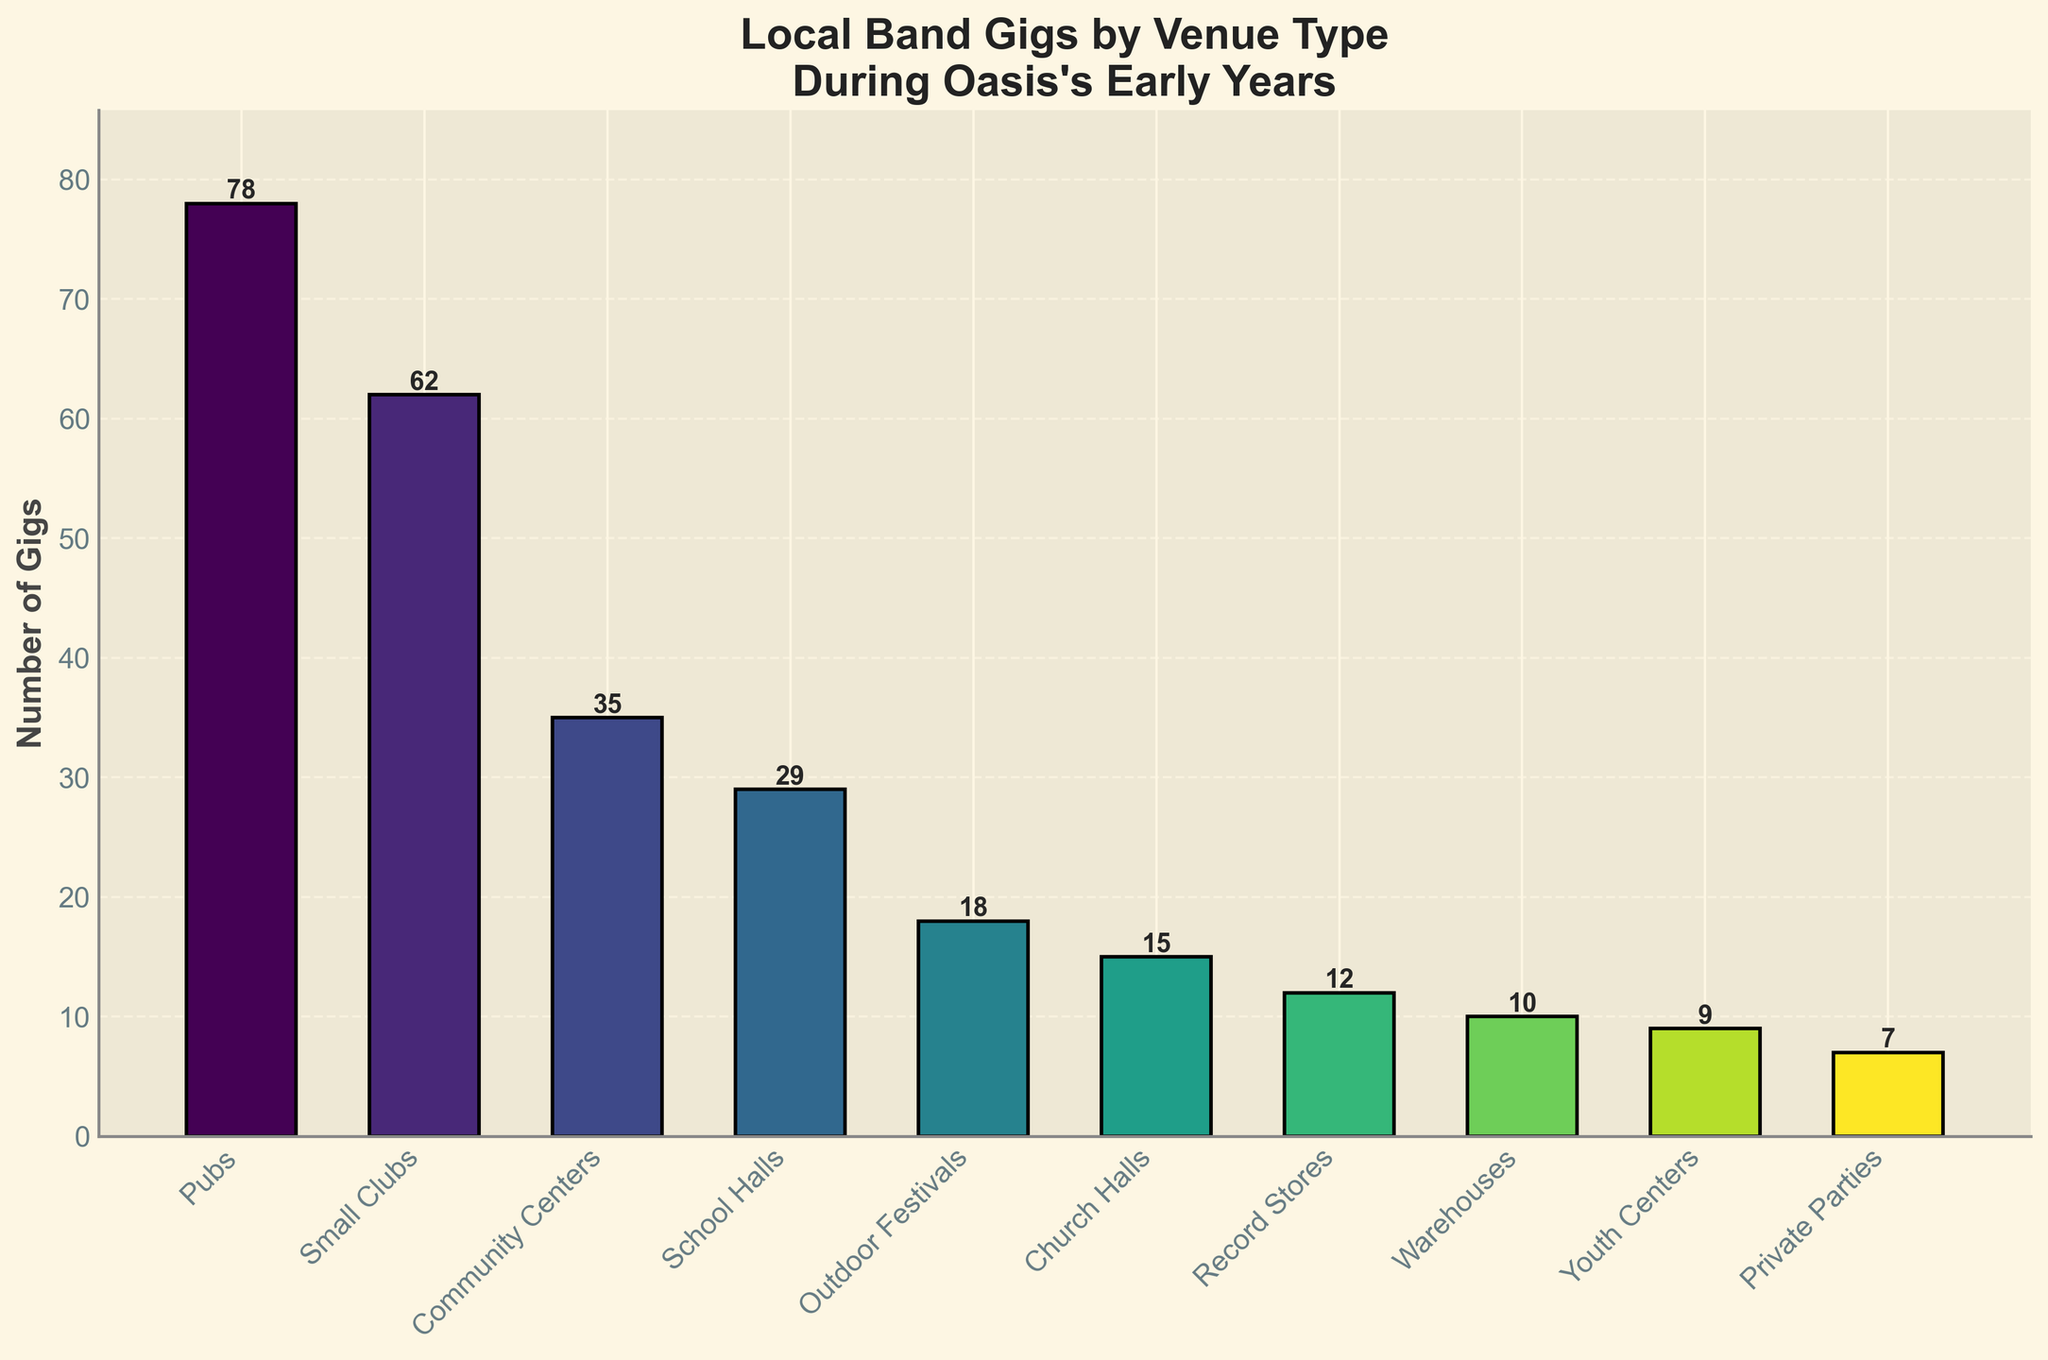Which venue type hosted the most gigs? The highest bar in the chart represents the venue type that hosted the most gigs. The bar for "Pubs" is the tallest.
Answer: Pubs How many gigs were played at Community Centers compared to School Halls? The bar representing Community Centers reaches up to 35, while the bar representing School Halls reaches up to 29.
Answer: Community Centers: 35, School Halls: 29 What is the total number of gigs played at Outdoor Festivals and Church Halls? Summing the heights of the bars for Outdoor Festivals (18) and Church Halls (15) gives the total number. 18 + 15 = 33
Answer: 33 Which venue type hosted the fewest gigs and how many were there? The shortest bar represents the venue type that hosted the fewest gigs. The bar for "Private Parties" is the shortest, reaching up to 7.
Answer: Private Parties, 7 How many more gigs were played at Small Clubs than at Warehouses? The height of the bar for Small Clubs is 62 and for Warehouses, it is 10. The difference is 62 - 10 = 52.
Answer: 52 What is the average number of gigs played across all recorded venue types? Adding up the heights of all bars and dividing by the number of venue types: (78 + 62 + 35 + 29 + 18 + 15 + 12 + 10 + 9 + 7) / 10 = 275 / 10 = 27.5
Answer: 27.5 How does the number of gigs at Record Stores compare to those at Warehouses? The bar for Record Stores reaches up to 12 and the bar for Warehouses reaches up to 10, so Record Stores hosted slightly more gigs.
Answer: Record Stores: 12, Warehouses: 10 What's the combined number of gigs played at venues classified as halls (School Halls, Church Halls, and Community Centers)? Summing the heights for School Halls (29), Church Halls (15), and Community Centers (35): 29 + 15 + 35 = 79
Answer: 79 Which type of venue had a number of gigs closest to the average number of gigs played across all venues? The average number of gigs is 27.5, and the closest value to this average is the number for School Halls, which is 29.
Answer: School Halls 